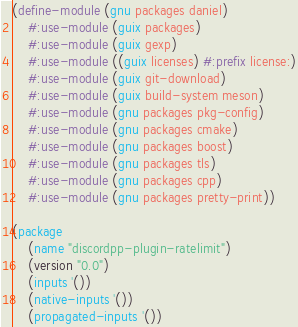<code> <loc_0><loc_0><loc_500><loc_500><_Scheme_>(define-module (gnu packages daniel)
	#:use-module (guix packages)
	#:use-module (guix gexp)
	#:use-module ((guix licenses) #:prefix license:)
	#:use-module (guix git-download)
	#:use-module (guix build-system meson)
	#:use-module (gnu packages pkg-config)
	#:use-module (gnu packages cmake)
	#:use-module (gnu packages boost)
	#:use-module (gnu packages tls)
	#:use-module (gnu packages cpp)
	#:use-module (gnu packages pretty-print))

(package
	(name "discordpp-plugin-ratelimit")
	(version "0.0")
	(inputs '())
	(native-inputs '())
	(propagated-inputs '())</code> 